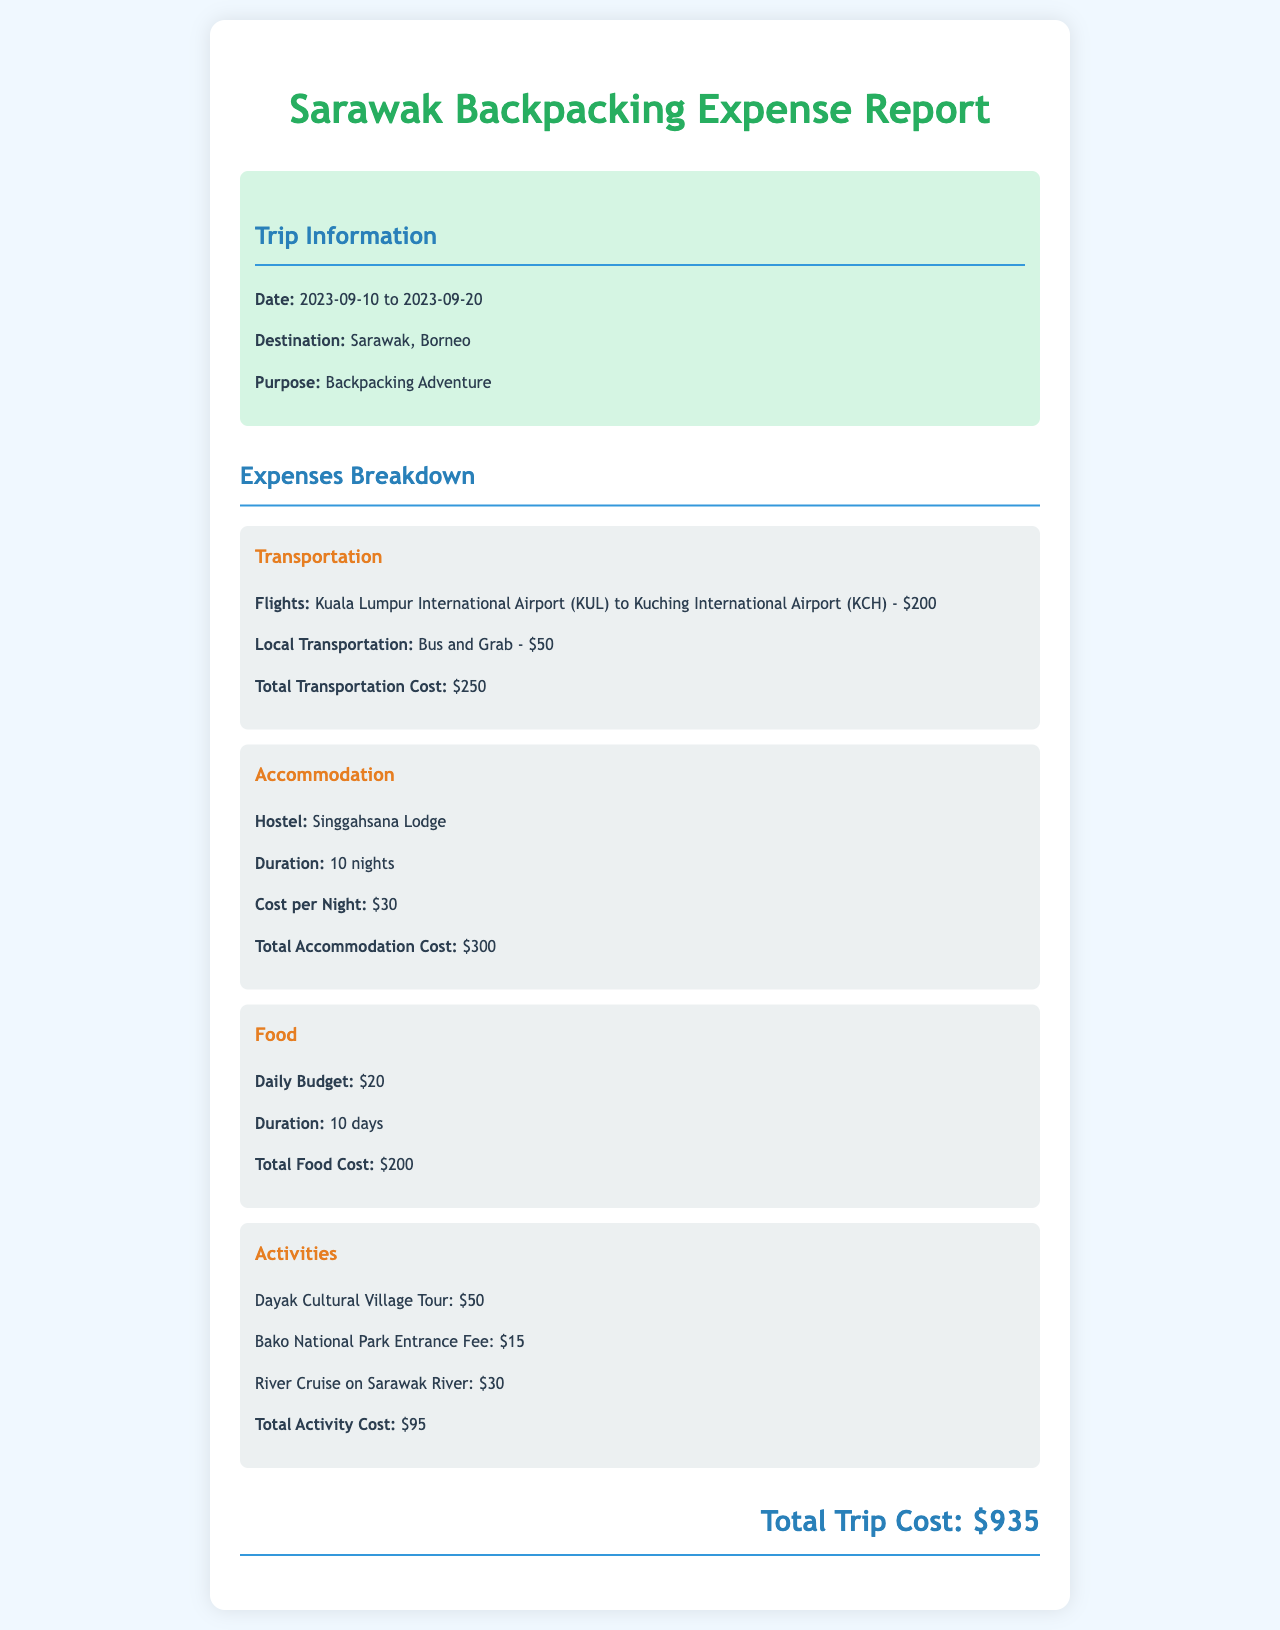What are the trip dates? The trip dates are provided in the document as "2023-09-10 to 2023-09-20."
Answer: 2023-09-10 to 2023-09-20 How much did the flights cost? The document clearly states the flight cost under transportation, which is $200.
Answer: $200 Where did the backpacker stay? The hostel name is mentioned under accommodation in the report as "Singgahsana Lodge."
Answer: Singgahsana Lodge What is the total food cost? The total food cost is calculated based on the daily budget and duration, totaling $200.
Answer: $200 What activity has the highest cost? The document lists activities with costs; the "Dayak Cultural Village Tour" costs $50, which is the highest.
Answer: Dayak Cultural Village Tour How many nights did the backpacker stay? The document specifies that the backpacker stayed for "10 nights."
Answer: 10 nights What was the total trip cost? The total trip cost is summed up at the end of the document as $935.
Answer: $935 How much was spent on local transportation? The local transportation cost is mentioned under transportation, which is $50.
Answer: $50 What is the duration of the trip? The duration is derived from the trip dates provided in the document, specifying a duration of 10 days.
Answer: 10 days 